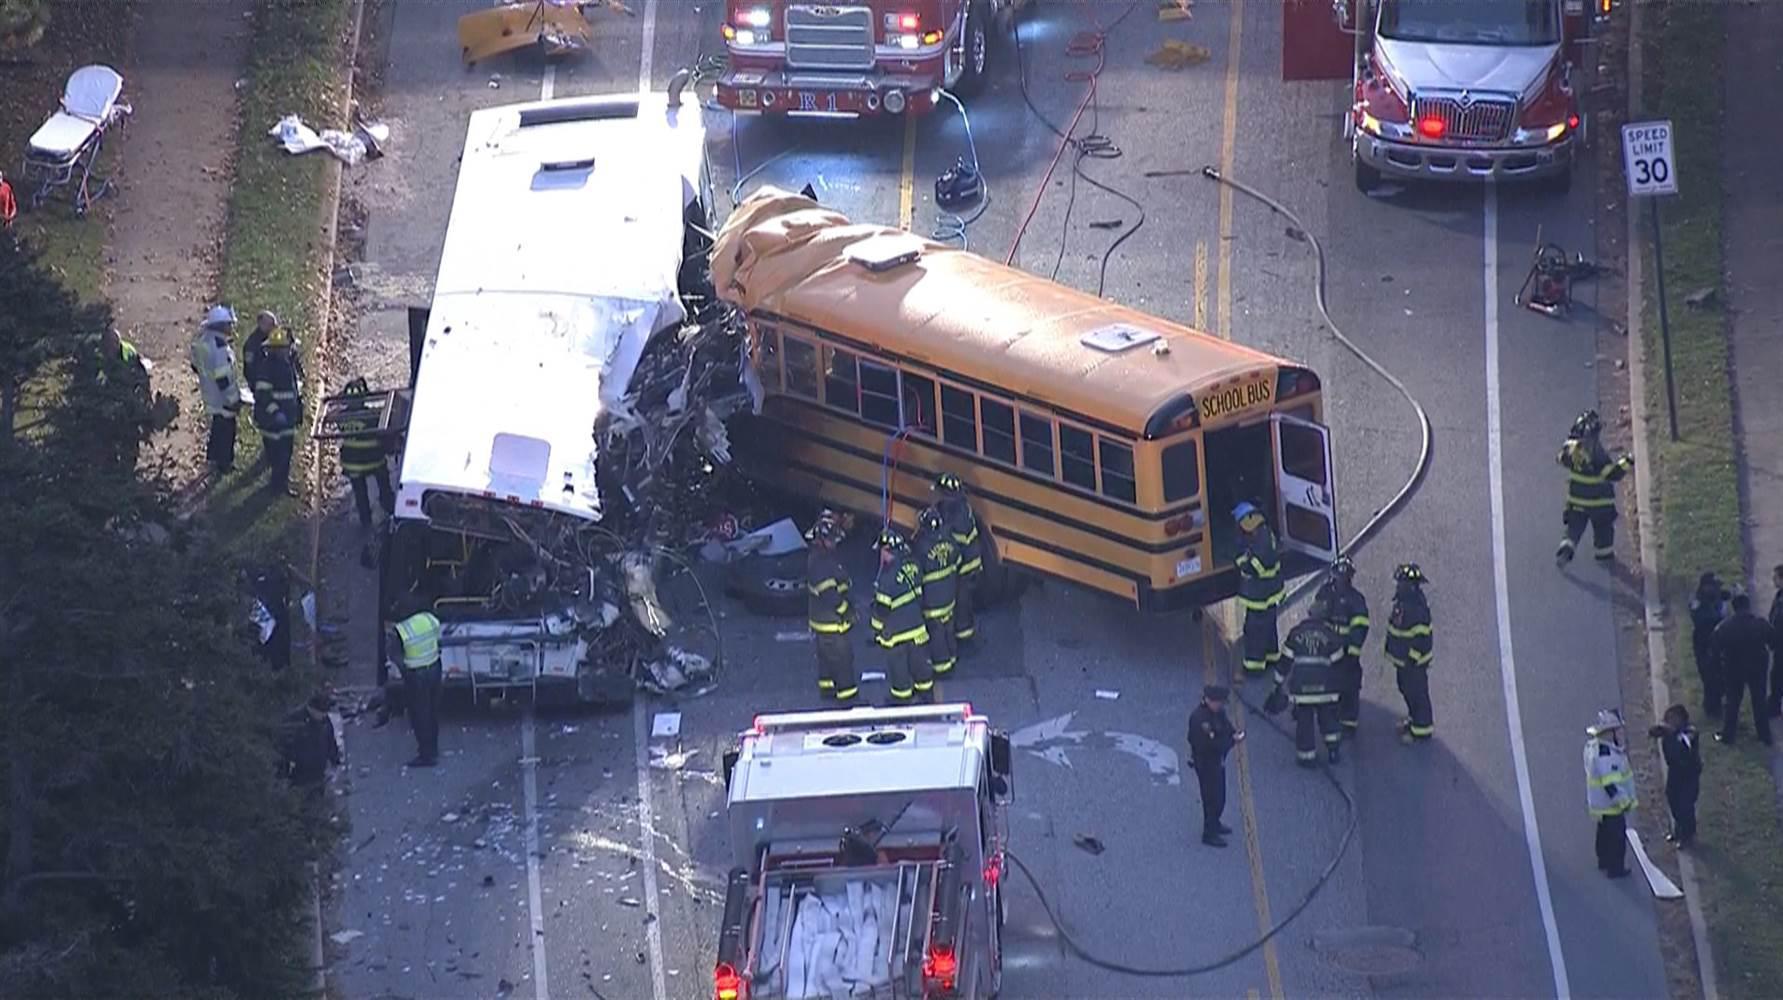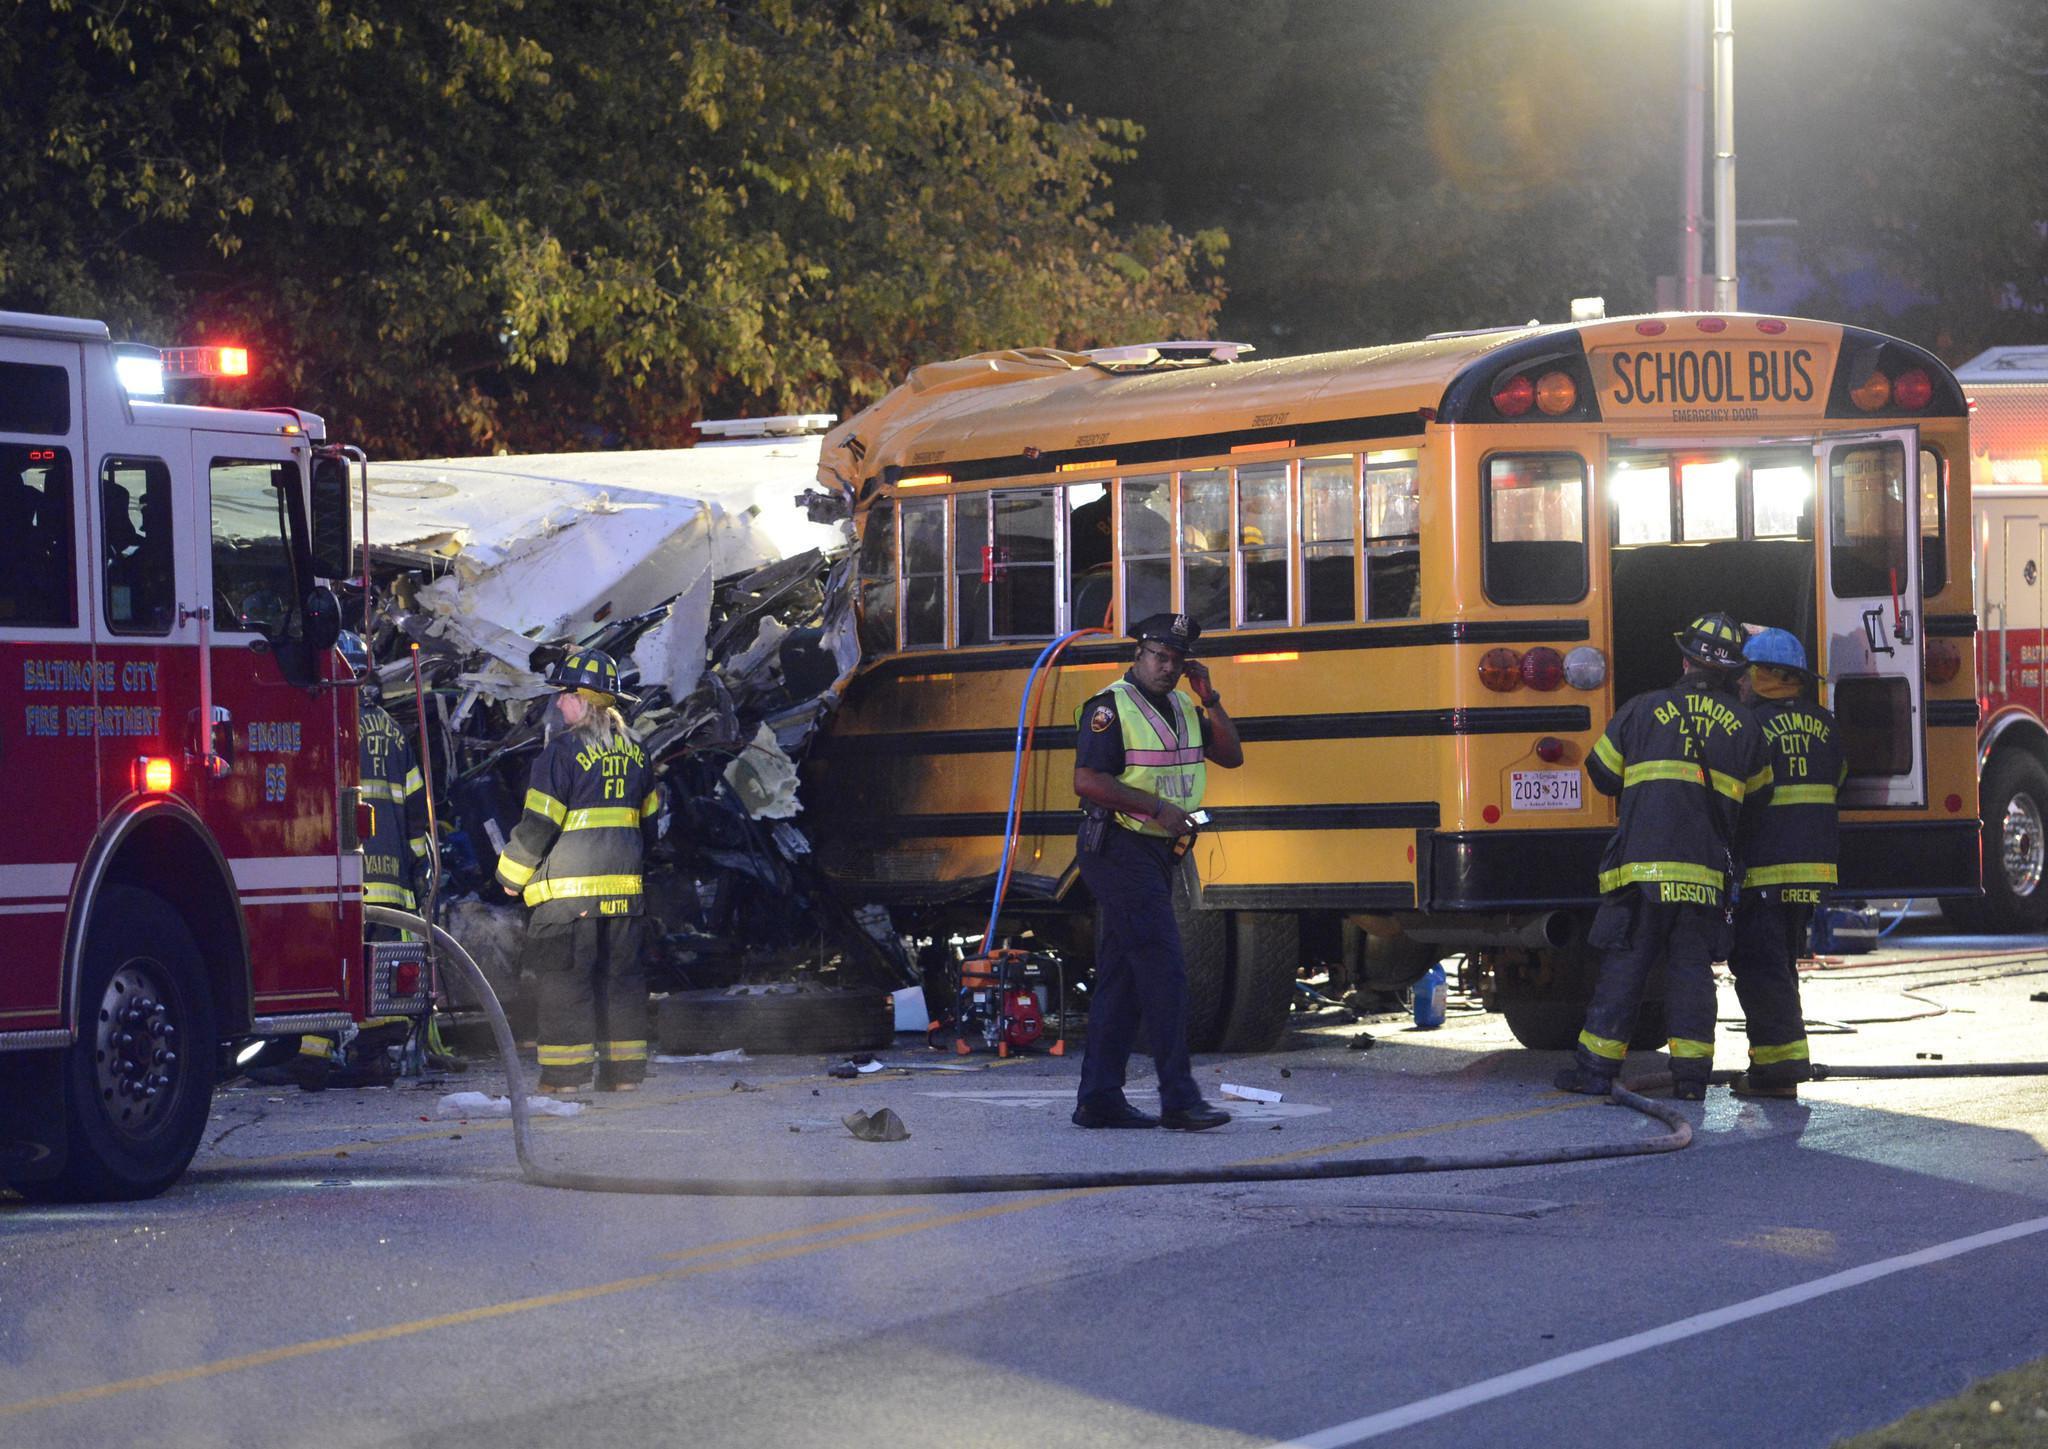The first image is the image on the left, the second image is the image on the right. Given the left and right images, does the statement "In at least one of the images, a school bus has plowed into a commuter bus." hold true? Answer yes or no. Yes. The first image is the image on the left, the second image is the image on the right. Examine the images to the left and right. Is the description "Firefighters dressed in their gear and people wearing yellow safety jackets are working at the scene of a bus accident in at least one of the images." accurate? Answer yes or no. Yes. 